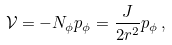Convert formula to latex. <formula><loc_0><loc_0><loc_500><loc_500>\mathcal { V } = - N _ { \phi } p _ { \phi } = \frac { J } { 2 r ^ { 2 } } p _ { \phi } \, ,</formula> 